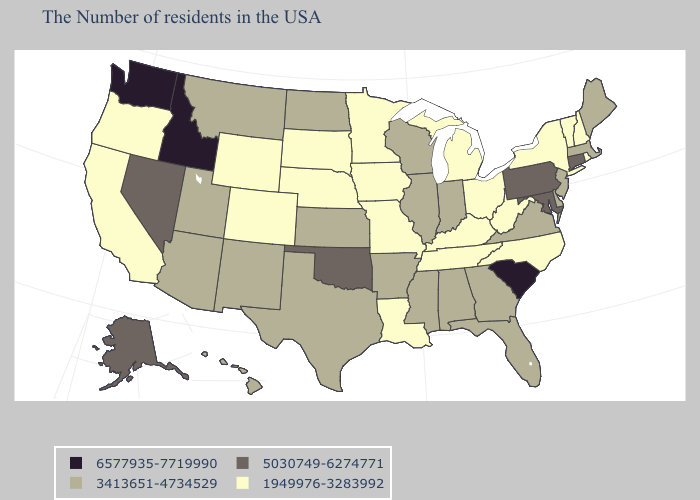Does New York have the lowest value in the Northeast?
Answer briefly. Yes. Name the states that have a value in the range 6577935-7719990?
Be succinct. South Carolina, Idaho, Washington. Among the states that border Rhode Island , which have the lowest value?
Write a very short answer. Massachusetts. Does Iowa have the highest value in the MidWest?
Give a very brief answer. No. Does Vermont have a lower value than Arizona?
Short answer required. Yes. Does New Mexico have the same value as Wyoming?
Keep it brief. No. What is the lowest value in the West?
Quick response, please. 1949976-3283992. Does Delaware have the lowest value in the South?
Give a very brief answer. No. Name the states that have a value in the range 5030749-6274771?
Be succinct. Connecticut, Maryland, Pennsylvania, Oklahoma, Nevada, Alaska. Name the states that have a value in the range 1949976-3283992?
Keep it brief. Rhode Island, New Hampshire, Vermont, New York, North Carolina, West Virginia, Ohio, Michigan, Kentucky, Tennessee, Louisiana, Missouri, Minnesota, Iowa, Nebraska, South Dakota, Wyoming, Colorado, California, Oregon. Which states hav the highest value in the South?
Concise answer only. South Carolina. What is the highest value in the USA?
Keep it brief. 6577935-7719990. Name the states that have a value in the range 5030749-6274771?
Write a very short answer. Connecticut, Maryland, Pennsylvania, Oklahoma, Nevada, Alaska. Among the states that border North Dakota , which have the lowest value?
Keep it brief. Minnesota, South Dakota. Which states hav the highest value in the South?
Short answer required. South Carolina. 